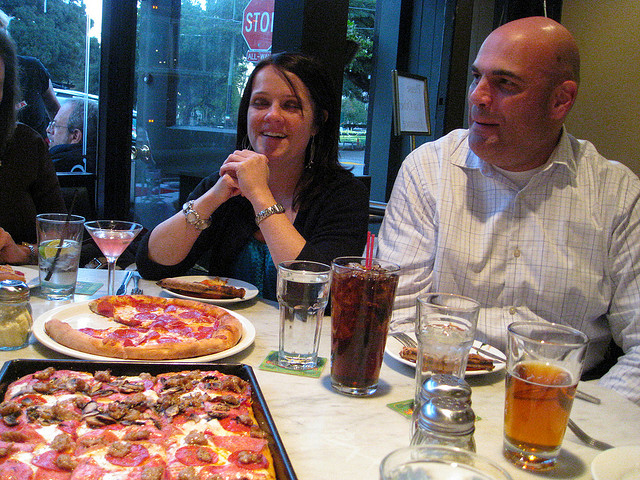How many pizzas are there? 2 